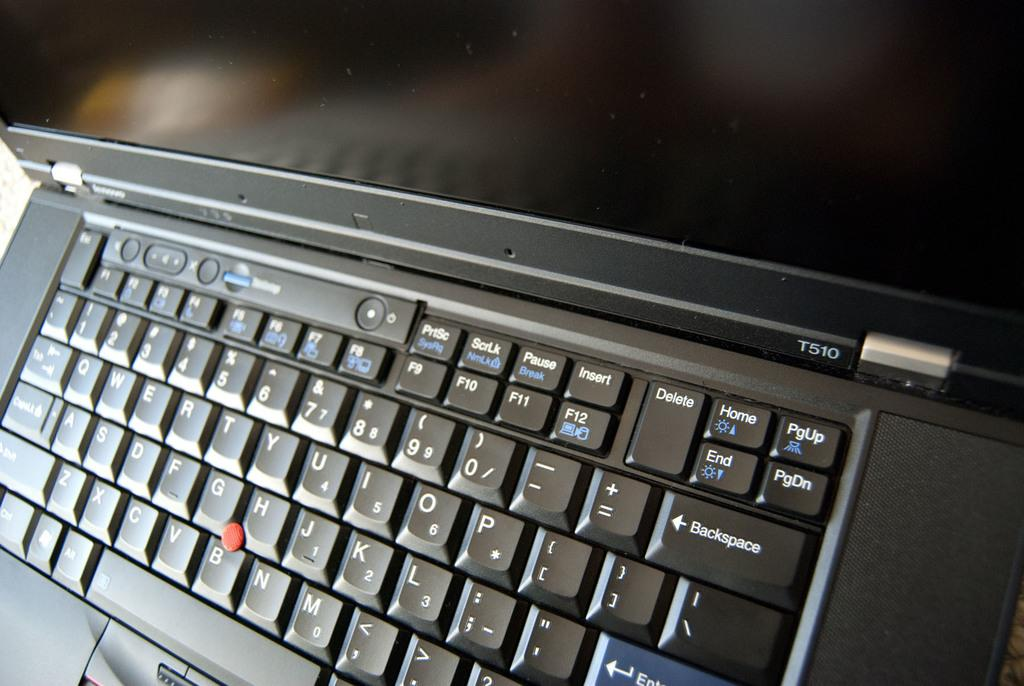Provide a one-sentence caption for the provided image. A laptop and keyboard with a PGUP key in the top right. 